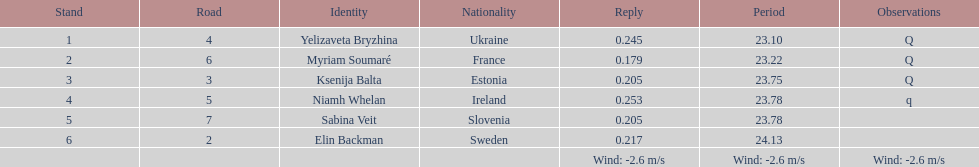The difference between yelizaveta bryzhina's time and ksenija balta's time? 0.65. 